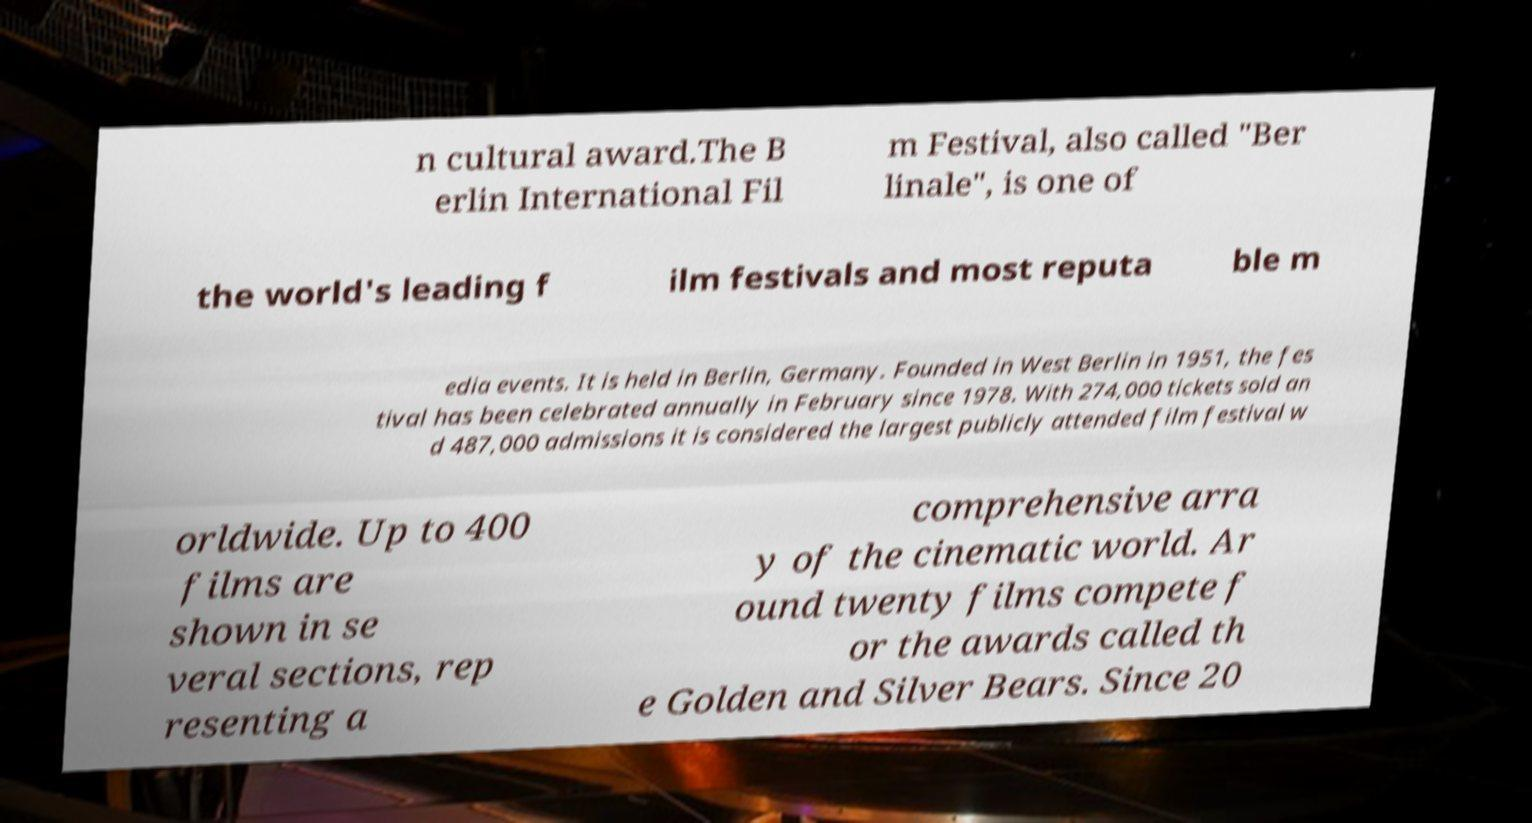Could you assist in decoding the text presented in this image and type it out clearly? n cultural award.The B erlin International Fil m Festival, also called "Ber linale", is one of the world's leading f ilm festivals and most reputa ble m edia events. It is held in Berlin, Germany. Founded in West Berlin in 1951, the fes tival has been celebrated annually in February since 1978. With 274,000 tickets sold an d 487,000 admissions it is considered the largest publicly attended film festival w orldwide. Up to 400 films are shown in se veral sections, rep resenting a comprehensive arra y of the cinematic world. Ar ound twenty films compete f or the awards called th e Golden and Silver Bears. Since 20 